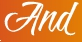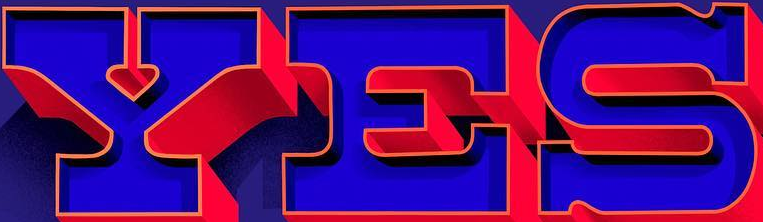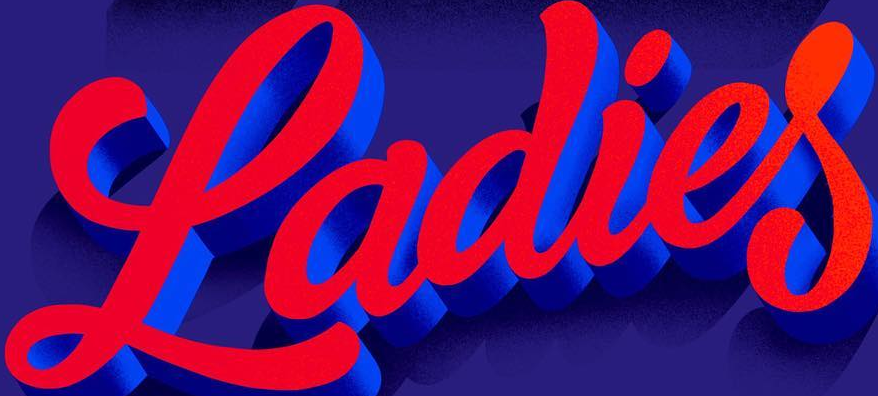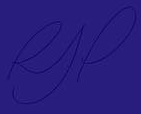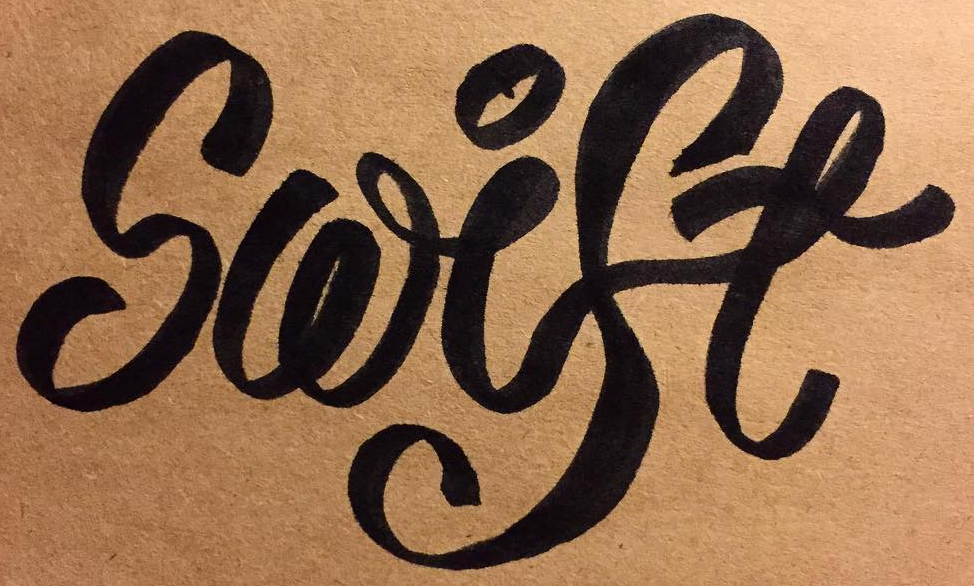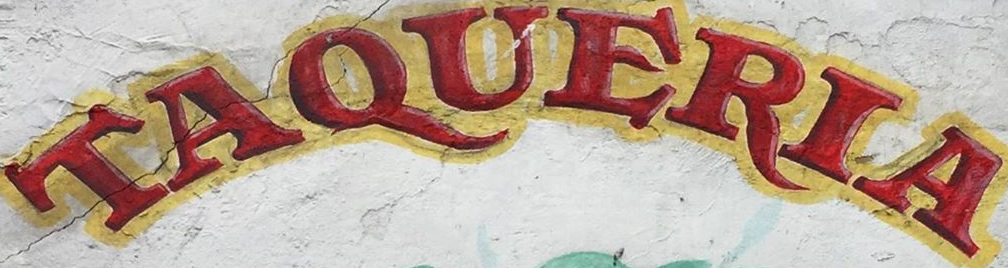Identify the words shown in these images in order, separated by a semicolon. And; YES; Ladies; RJP; Swise; TAQUERIA 